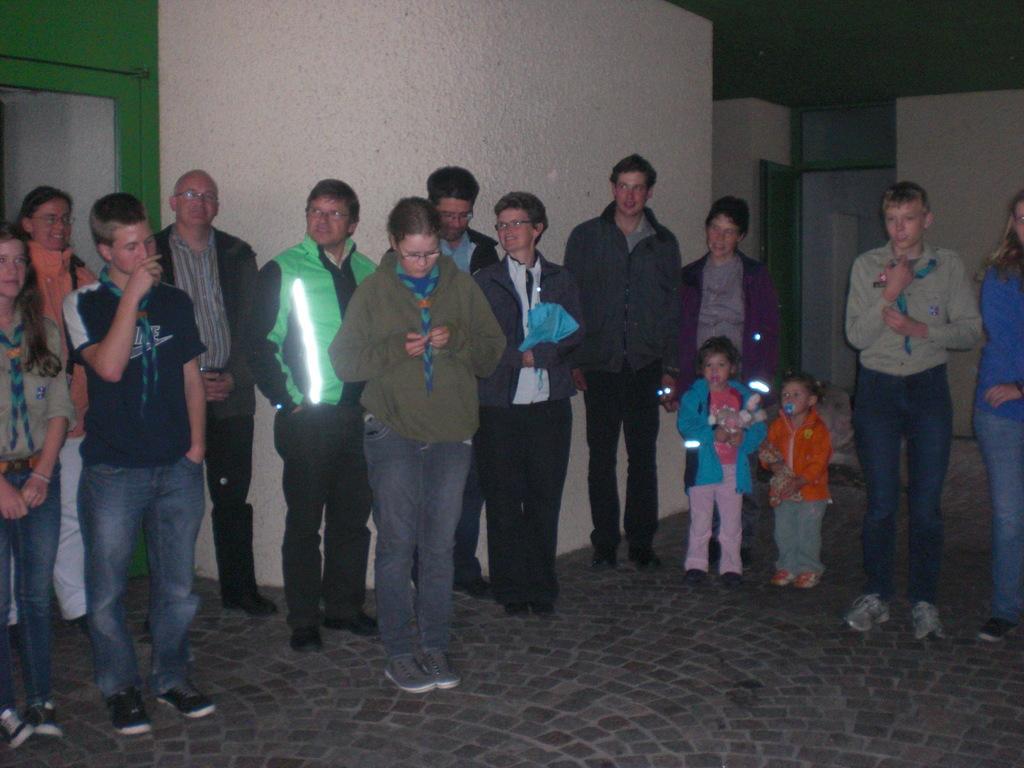Can you describe this image briefly? Here in this picture we can see some people and children are standing on the ground over there and we can see most of them are wearing jackets on them and some of them are also wearing spectacles on them and behind them on them on the right side we can see a door present over there. 